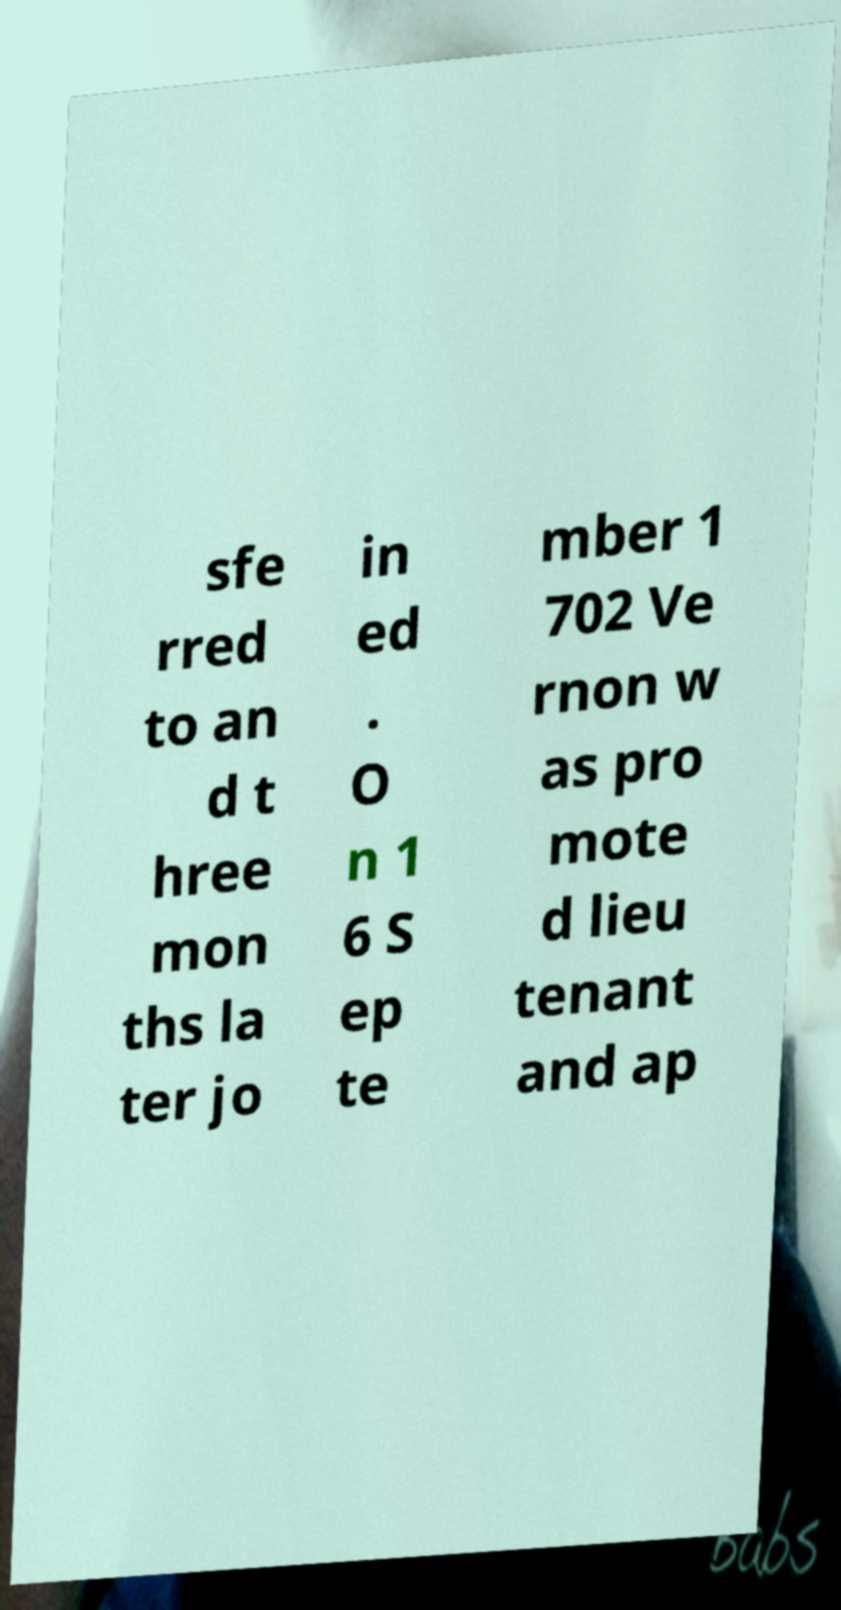For documentation purposes, I need the text within this image transcribed. Could you provide that? sfe rred to an d t hree mon ths la ter jo in ed . O n 1 6 S ep te mber 1 702 Ve rnon w as pro mote d lieu tenant and ap 